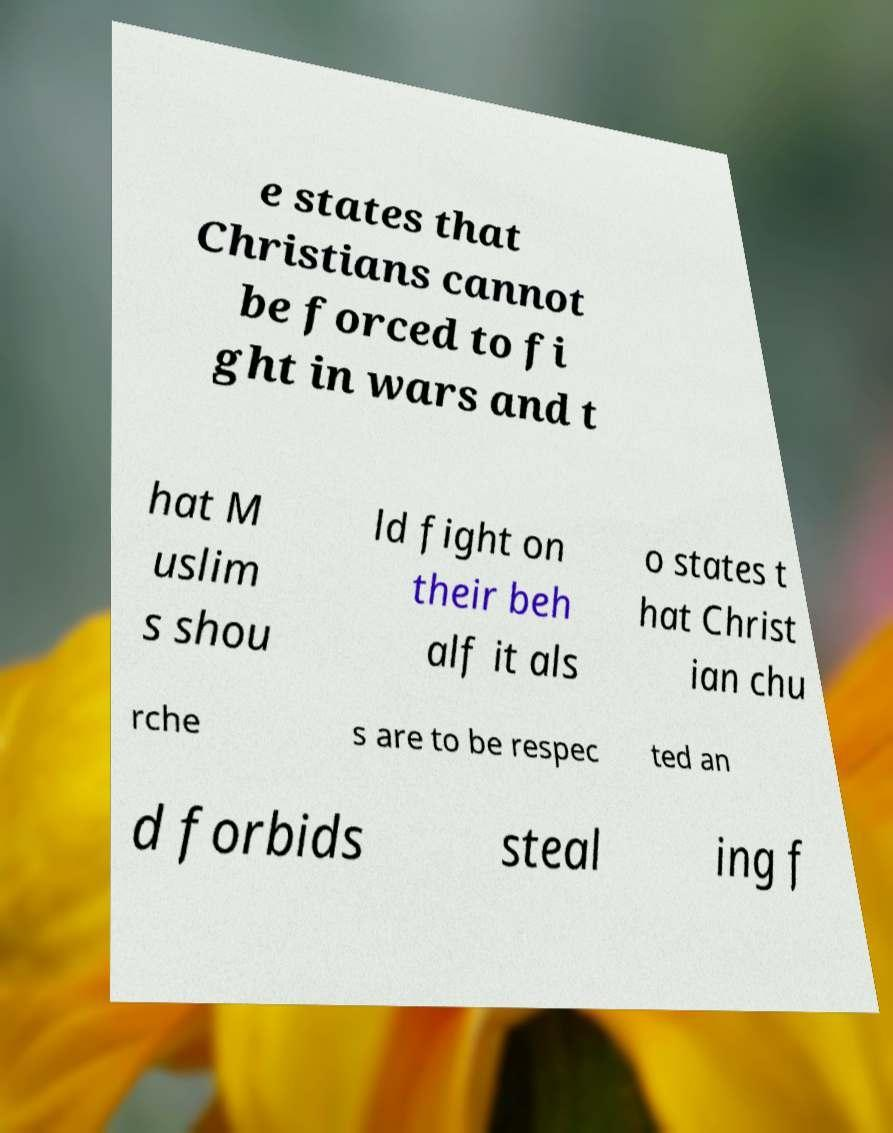Can you accurately transcribe the text from the provided image for me? e states that Christians cannot be forced to fi ght in wars and t hat M uslim s shou ld fight on their beh alf it als o states t hat Christ ian chu rche s are to be respec ted an d forbids steal ing f 